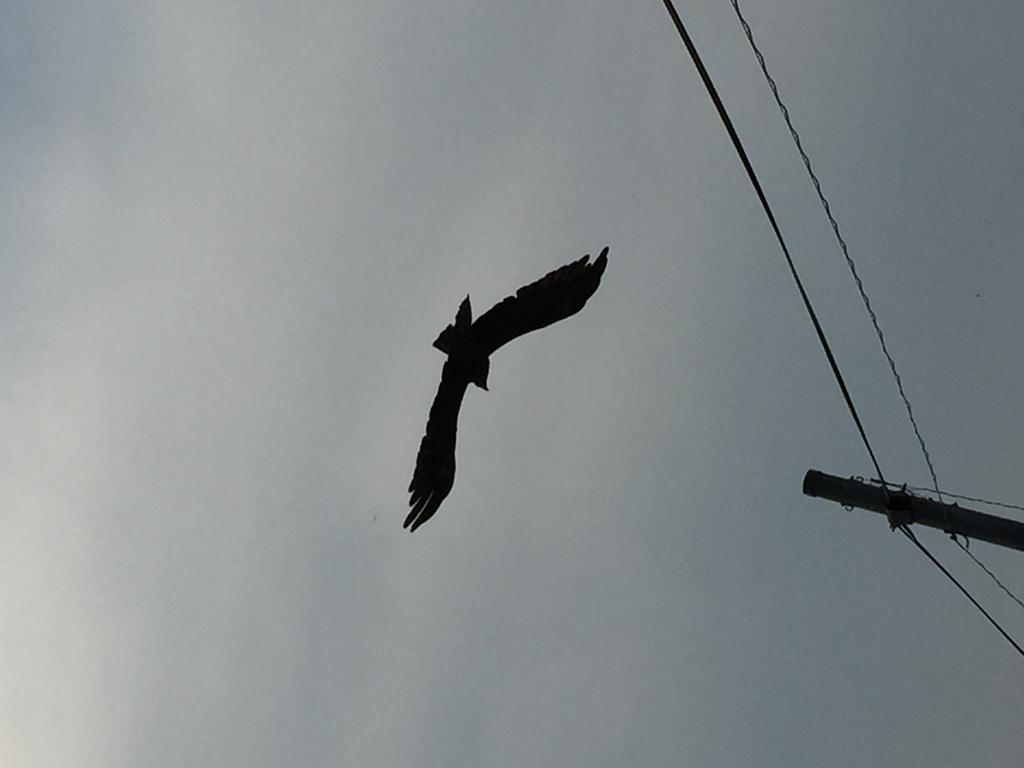What is the main subject of the image? There is a bird flying in the center of the image. What can be seen on the right side of the image? There are cables and a pole on the right side of the image. How would you describe the sky in the image? The sky is cloudy. Can you see any lines of salt on the ground in the image? There is no mention of salt or lines on the ground in the image. 